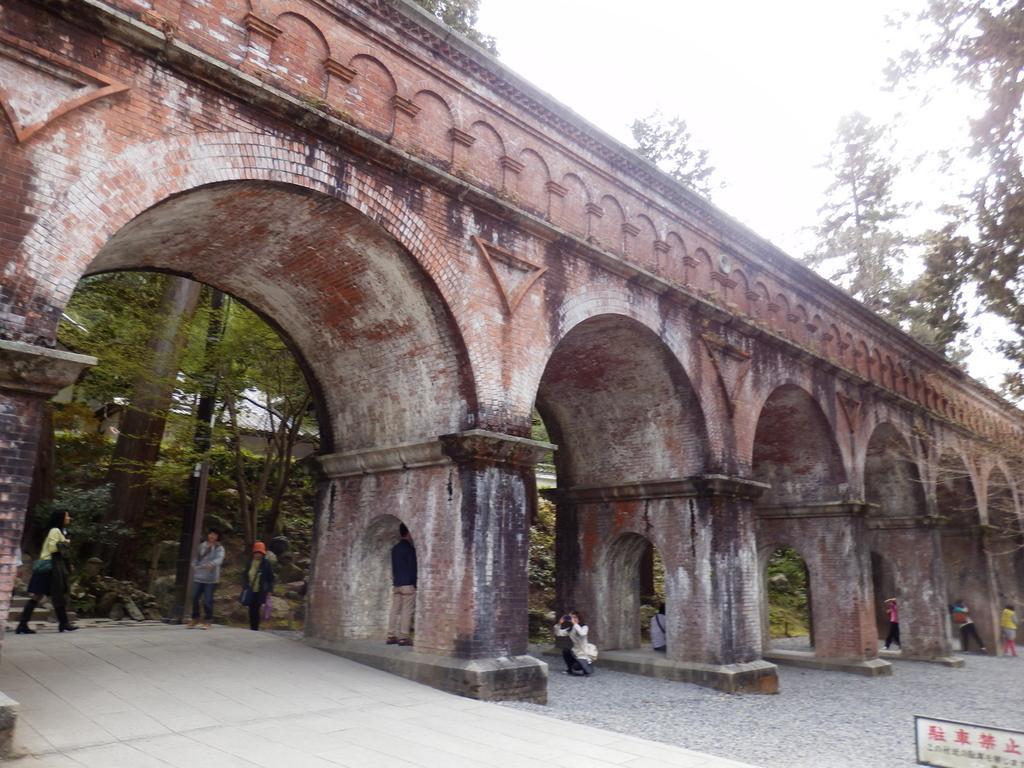In one or two sentences, can you explain what this image depicts? Here we can see a bridge with arch. There are few persons. Here we can see a board, pole, and trees. In the background there is sky. 